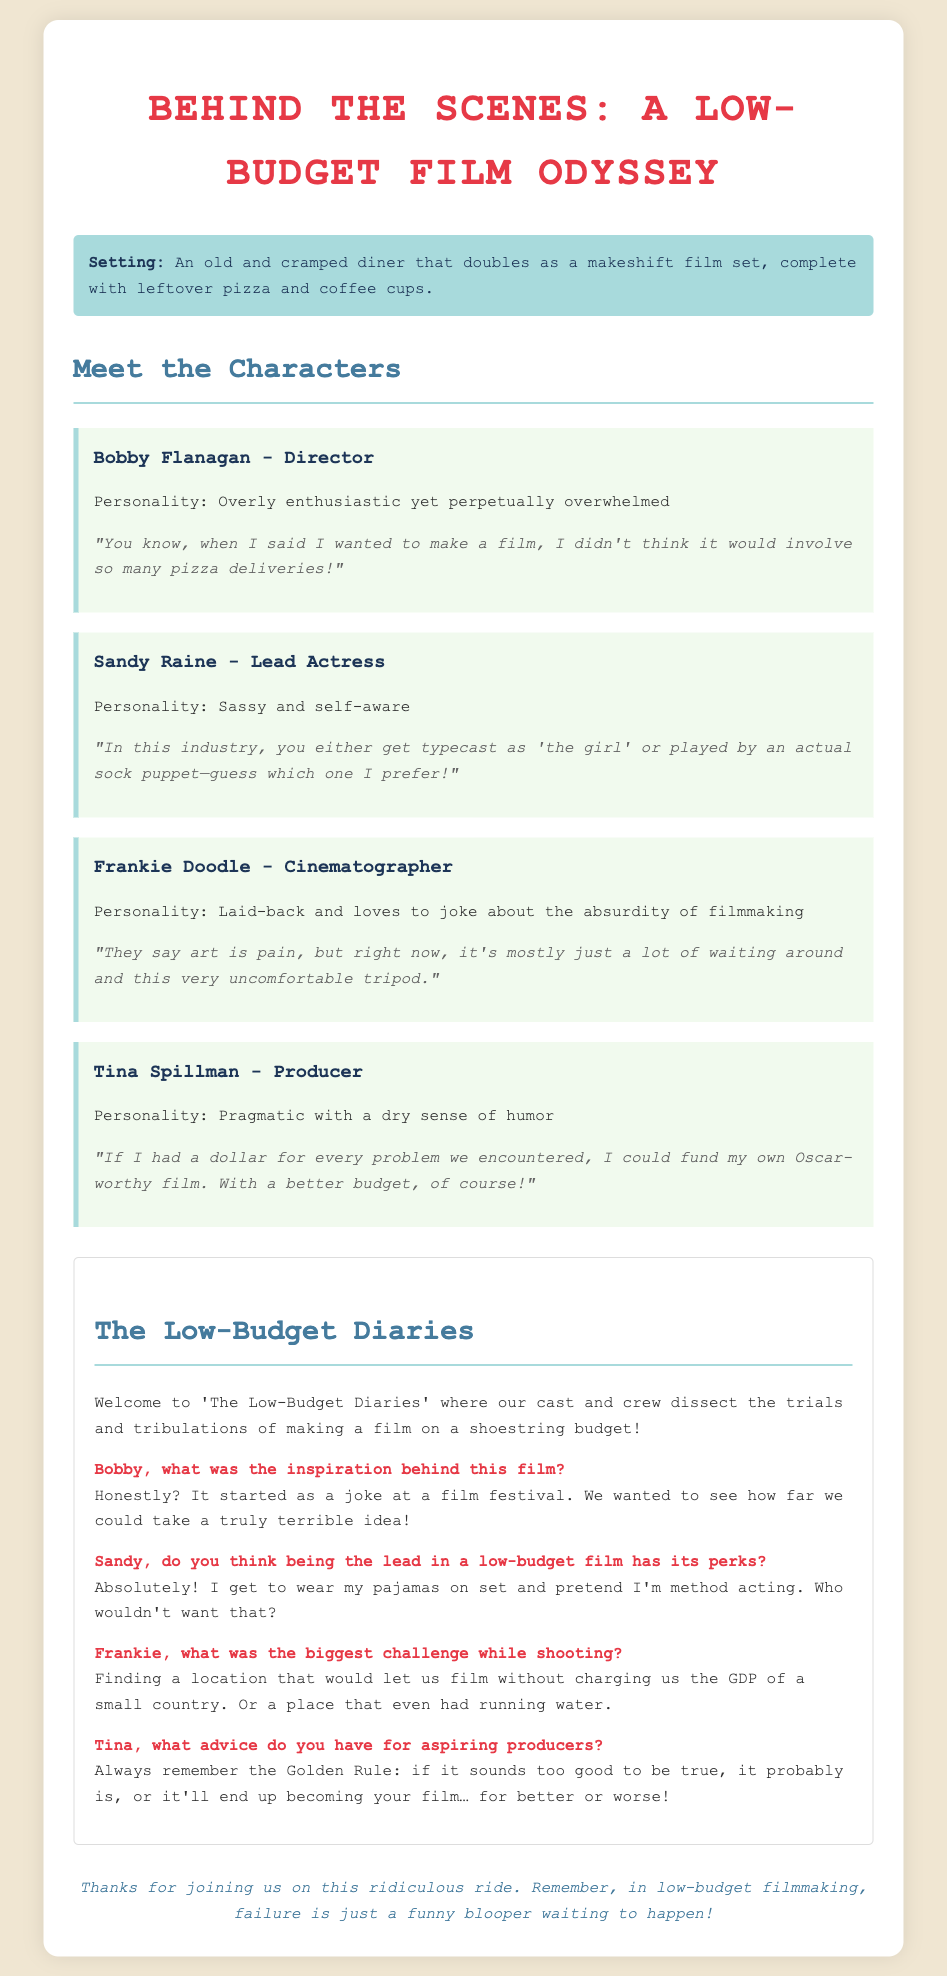What is the title of the mock interview script? The title of the script is stated in the document header.
Answer: Behind the Scenes: A Low-Budget Film Odyssey Who is the lead actress in the mock interview? The document provides the name of the lead actress under the character section.
Answer: Sandy Raine What is Bobby Flanagan's role in the film production? Bobby Flanagan's role is mentioned in the character section of the document.
Answer: Director What humorous comment does Frankie Doodle make about filmmaking? The specific humorous comment about filmmaking is quoted in Frankie Doodle's character description.
Answer: "They say art is pain, but right now, it's mostly just a lot of waiting around and this very uncomfortable tripod." What advice does Tina Spillman give for aspiring producers? The advice is found in the interview section, coming from Tina Spillman.
Answer: "Always remember the Golden Rule: if it sounds too good to be true, it probably is..." What setting does the film take place in? The setting is described at the beginning of the document before introducing the characters.
Answer: An old and cramped diner What was the inspiration behind the film according to Bobby? Bobby shares the inspiration in the interview section.
Answer: A joke at a film festival What type of humor is prominent in the characters' quotes? The nature of humor is inferred from the content of their quotes throughout the document.
Answer: Self-referentiality and satire 